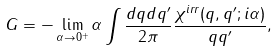<formula> <loc_0><loc_0><loc_500><loc_500>G = - \lim _ { \alpha \rightarrow 0 ^ { + } } \alpha \int \frac { d q d q ^ { \prime } } { 2 \pi } \frac { \chi ^ { i r r } ( q , q ^ { \prime } ; i \alpha ) } { q q ^ { \prime } } ,</formula> 